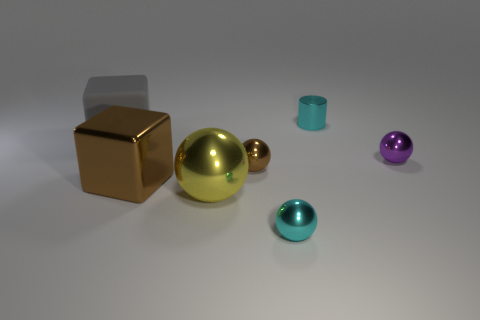Subtract all small spheres. How many spheres are left? 1 Subtract all gray blocks. How many blocks are left? 1 Subtract 1 spheres. How many spheres are left? 3 Add 1 purple balls. How many objects exist? 8 Subtract all red blocks. Subtract all blue spheres. How many blocks are left? 2 Subtract all gray cubes. How many cyan spheres are left? 1 Subtract all big gray rubber blocks. Subtract all big gray rubber cubes. How many objects are left? 5 Add 2 metal blocks. How many metal blocks are left? 3 Add 1 small brown metallic spheres. How many small brown metallic spheres exist? 2 Subtract 0 green cylinders. How many objects are left? 7 